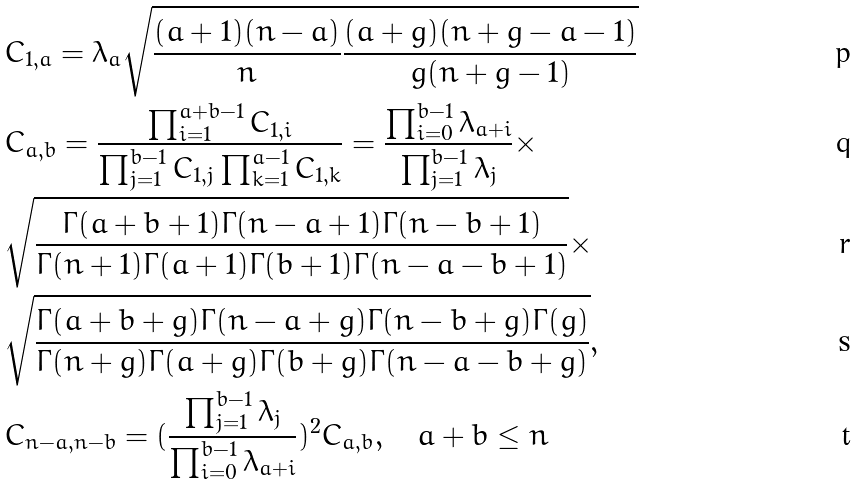<formula> <loc_0><loc_0><loc_500><loc_500>& C _ { 1 , a } = \lambda _ { a } \sqrt { \frac { ( a + 1 ) ( n - a ) } { n } \frac { ( a + g ) ( n + g - a - 1 ) } { g ( n + g - 1 ) } } \\ & C _ { a , b } = \frac { \prod _ { i = 1 } ^ { a + b - 1 } C _ { 1 , i } } { \prod _ { j = 1 } ^ { b - 1 } C _ { 1 , j } \prod _ { k = 1 } ^ { a - 1 } C _ { 1 , k } } = \frac { \prod _ { i = 0 } ^ { b - 1 } \lambda _ { a + i } } { \prod _ { j = 1 } ^ { b - 1 } \lambda _ { j } } \times \\ & \sqrt { \frac { \Gamma ( a + b + 1 ) \Gamma ( n - a + 1 ) \Gamma ( n - b + 1 ) } { \Gamma ( n + 1 ) \Gamma ( a + 1 ) \Gamma ( b + 1 ) \Gamma ( n - a - b + 1 ) } } \times \\ & \sqrt { \frac { \Gamma ( a + b + g ) \Gamma ( n - a + g ) \Gamma ( n - b + g ) \Gamma ( g ) } { \Gamma ( n + g ) \Gamma ( a + g ) \Gamma ( b + g ) \Gamma ( n - a - b + g ) } } , \\ & C _ { n - a , n - b } = ( \frac { \prod _ { j = 1 } ^ { b - 1 } \lambda _ { j } } { \prod _ { i = 0 } ^ { b - 1 } \lambda _ { a + i } } ) ^ { 2 } C _ { a , b } , \quad a + b \leq n</formula> 